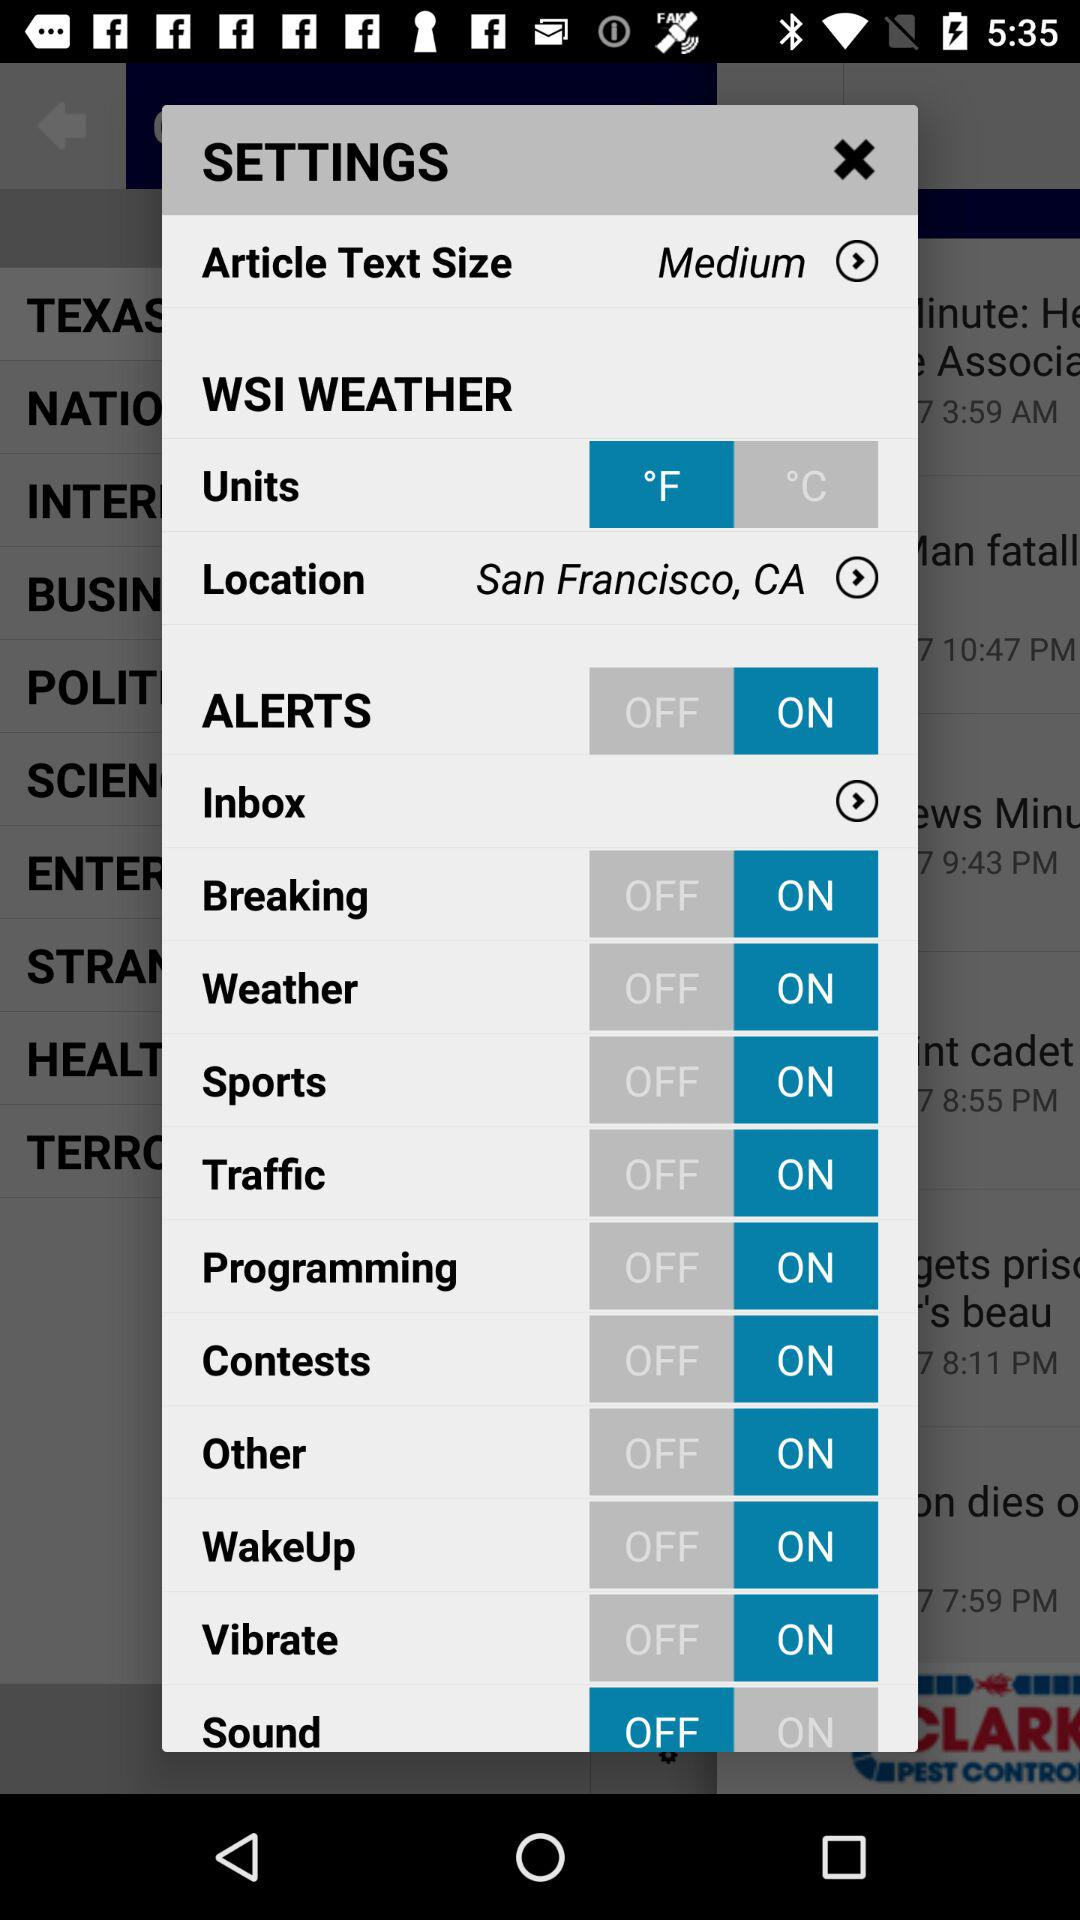Which option is selected for "Units"? The selected option is "°F". 